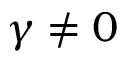Convert formula to latex. <formula><loc_0><loc_0><loc_500><loc_500>\gamma \neq 0</formula> 